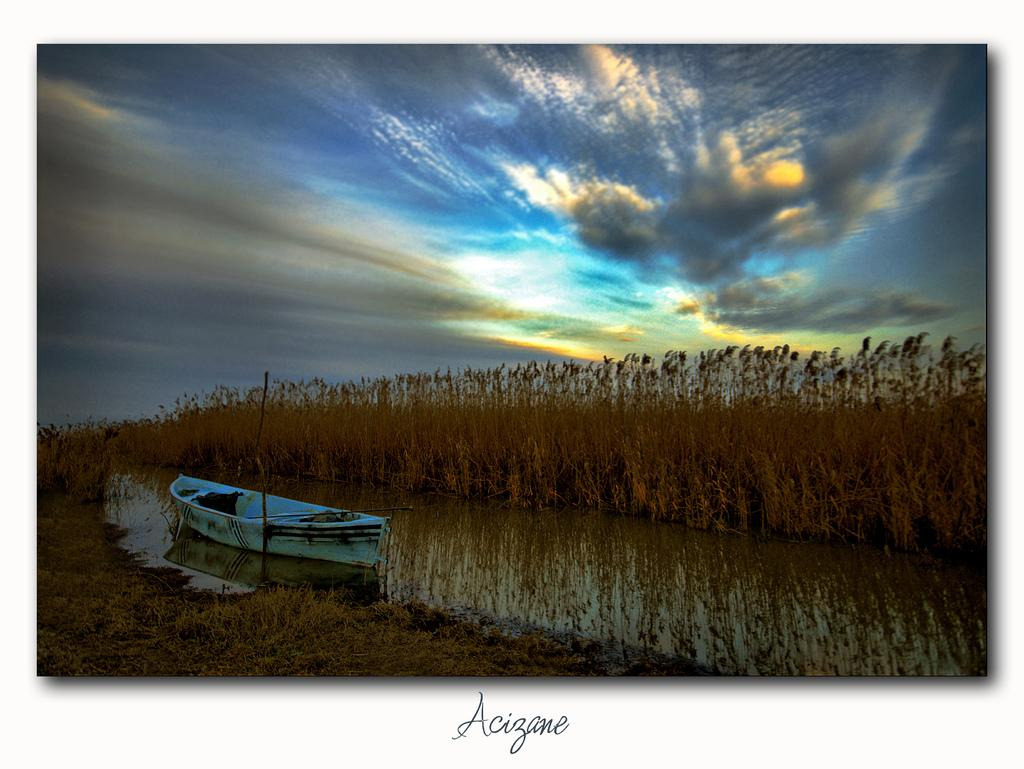What is the nature of the image? The image appears to be edited. What can be seen on the water in the image? There is a boat on the water. What type of vegetation is visible in the background? There are plants visible in the background. What is visible in the sky in the image? The sky is visible in the background. What is written on the image? There is text written on the image. What position does the hand take in the image? There is no hand present in the image. In which room is the boat located in the image? The image does not depict a room; it shows a boat on the water. 